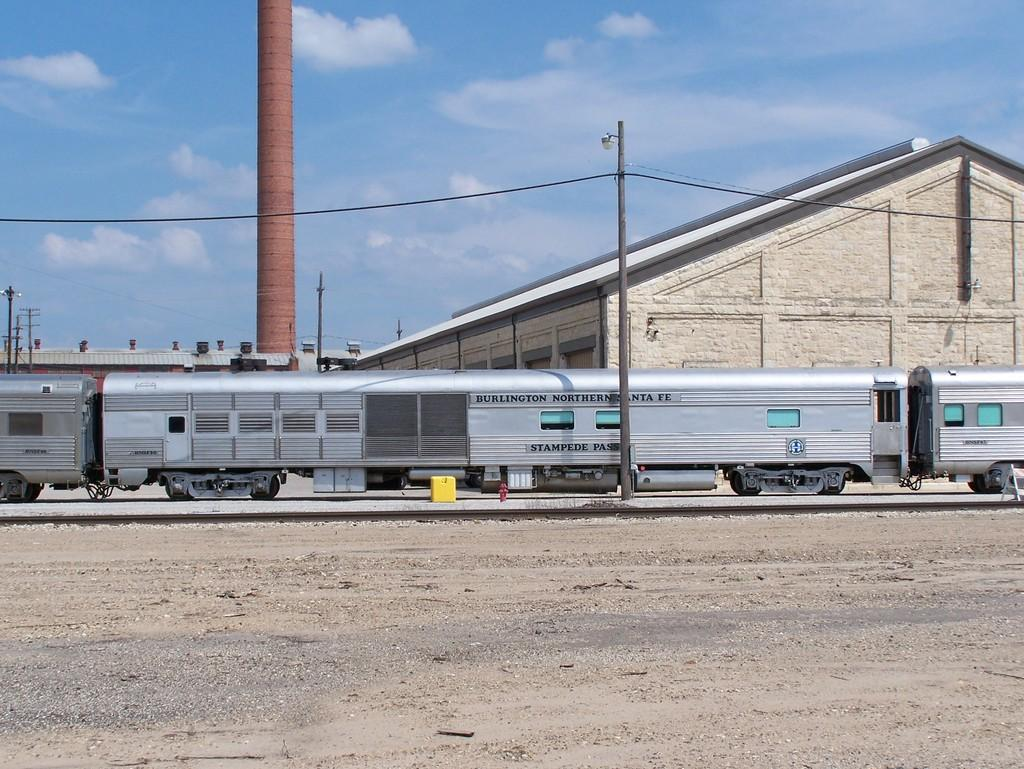What structures can be seen in the image? There are poles and sheds in the image. What mode of transportation is present in the image? There is a train in the image. What is the condition of the sky in the image? The sky is cloudy in the image. How many deer can be seen in the image? There are no deer present in the image. What type of pest is causing damage to the sheds in the image? There is no indication of any pest causing damage to the sheds in the image. 